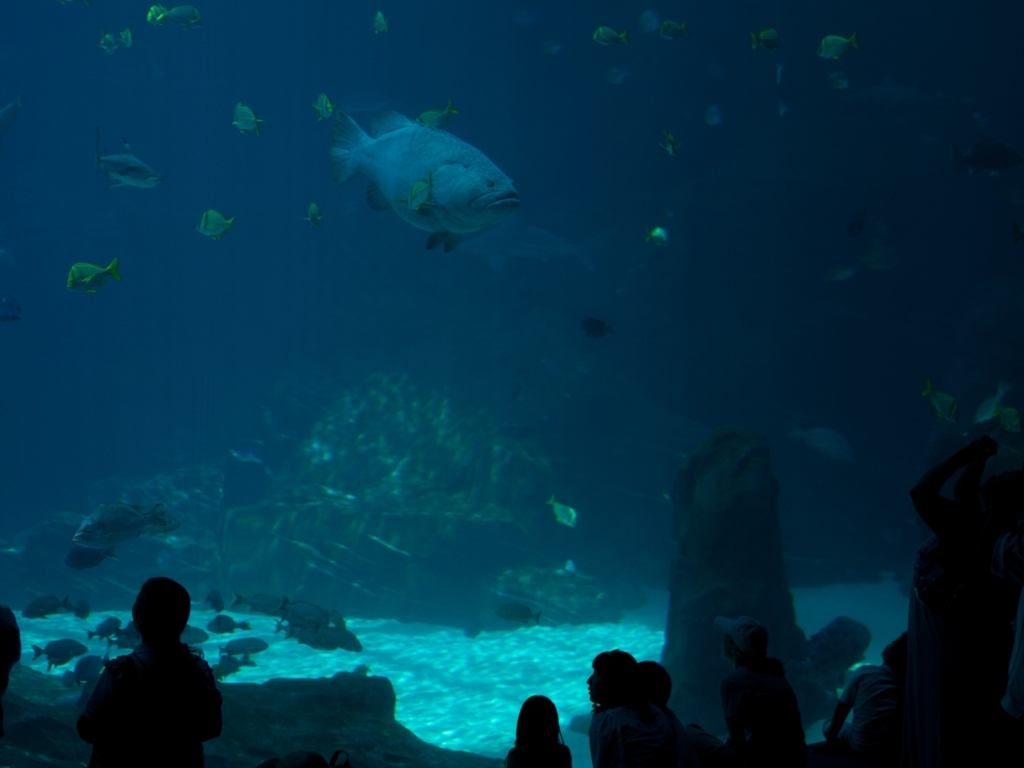What is the color contrast of the photo like?
A. Very low
B. Moderate
C. Slightly lower The color contrast in the photo is relatively moderate. Although the lighting is dim, creating an underwater ambiance, there are still discernible differences in hues between the aquatic blues and the shapes of fish and rocks. The illuminated portions, particularly near the bottom of the image, stand out against the darker areas, providing a balanced visual contrast. 